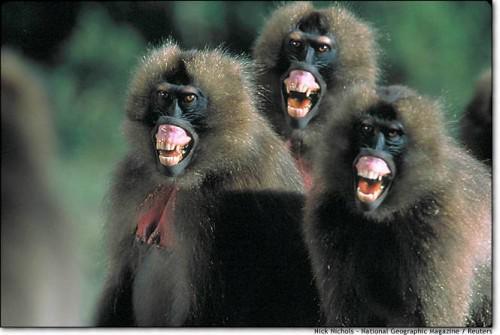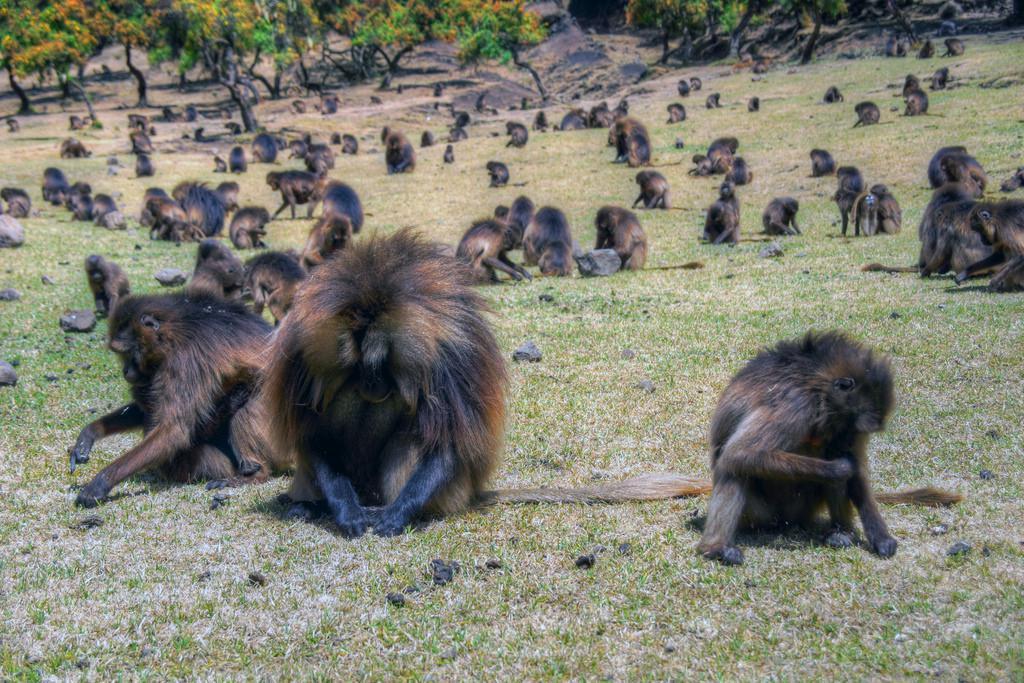The first image is the image on the left, the second image is the image on the right. Examine the images to the left and right. Is the description "One image has words." accurate? Answer yes or no. No. The first image is the image on the left, the second image is the image on the right. Given the left and right images, does the statement "There are monkeys sitting on grass." hold true? Answer yes or no. Yes. 